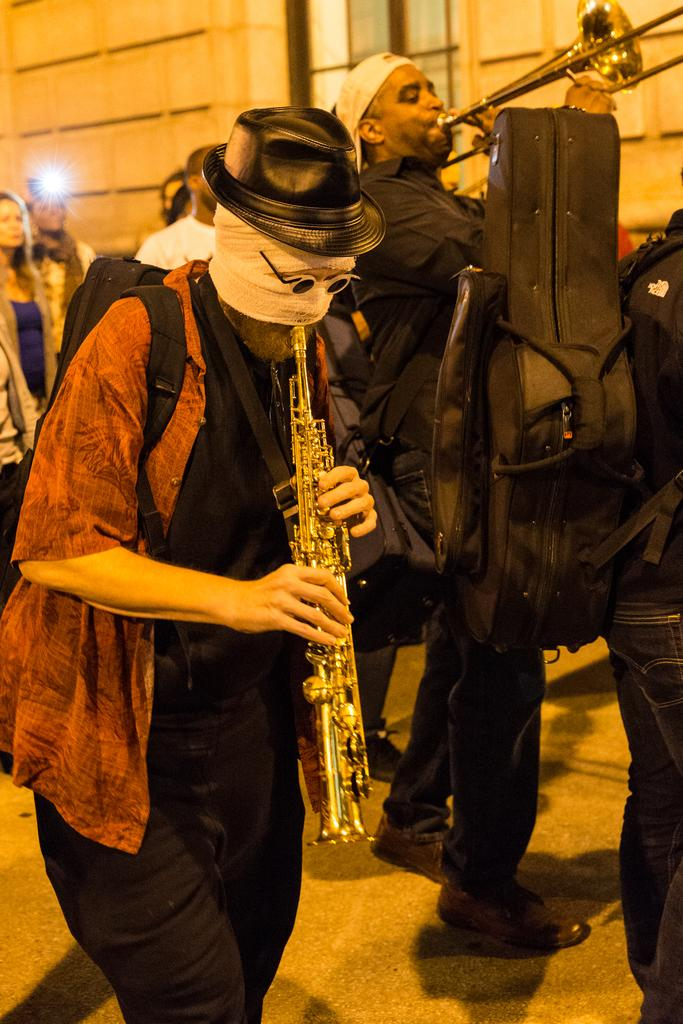How many people are present in the image? There are many people in the image. What are some of the people doing in the image? Some people are playing musical instruments. Can you describe the person on the right side of the image? A person is carrying an object on his back at the right side of the image. What type of ray can be seen swimming in the image? There is no ray present in the image; it features people and musical instruments. What is the opinion of the person carrying the object on his back? The image does not provide any information about the person's opinion, as it only shows their physical actions. 